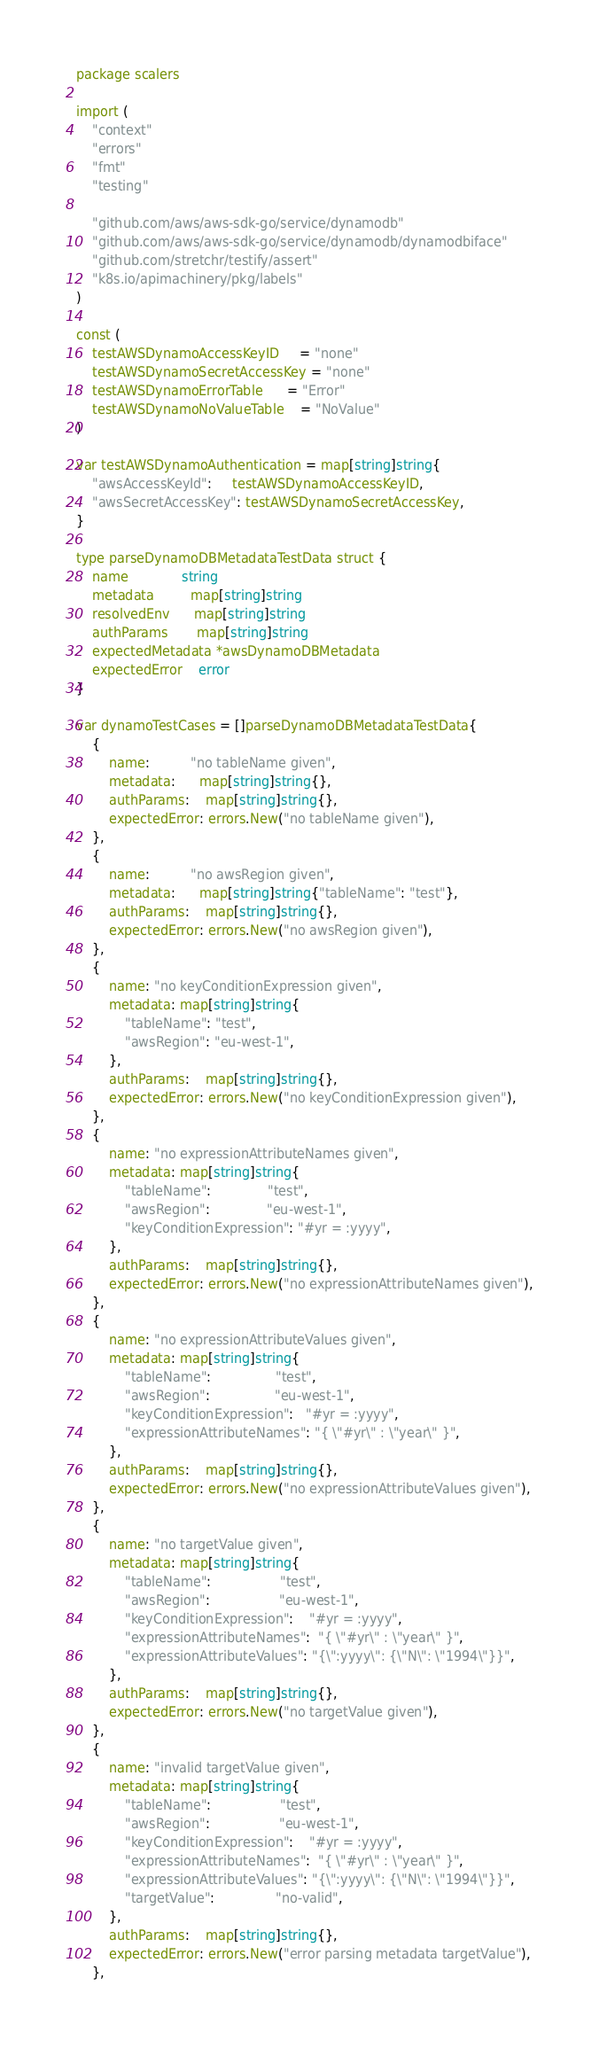Convert code to text. <code><loc_0><loc_0><loc_500><loc_500><_Go_>package scalers

import (
	"context"
	"errors"
	"fmt"
	"testing"

	"github.com/aws/aws-sdk-go/service/dynamodb"
	"github.com/aws/aws-sdk-go/service/dynamodb/dynamodbiface"
	"github.com/stretchr/testify/assert"
	"k8s.io/apimachinery/pkg/labels"
)

const (
	testAWSDynamoAccessKeyID     = "none"
	testAWSDynamoSecretAccessKey = "none"
	testAWSDynamoErrorTable      = "Error"
	testAWSDynamoNoValueTable    = "NoValue"
)

var testAWSDynamoAuthentication = map[string]string{
	"awsAccessKeyId":     testAWSDynamoAccessKeyID,
	"awsSecretAccessKey": testAWSDynamoSecretAccessKey,
}

type parseDynamoDBMetadataTestData struct {
	name             string
	metadata         map[string]string
	resolvedEnv      map[string]string
	authParams       map[string]string
	expectedMetadata *awsDynamoDBMetadata
	expectedError    error
}

var dynamoTestCases = []parseDynamoDBMetadataTestData{
	{
		name:          "no tableName given",
		metadata:      map[string]string{},
		authParams:    map[string]string{},
		expectedError: errors.New("no tableName given"),
	},
	{
		name:          "no awsRegion given",
		metadata:      map[string]string{"tableName": "test"},
		authParams:    map[string]string{},
		expectedError: errors.New("no awsRegion given"),
	},
	{
		name: "no keyConditionExpression given",
		metadata: map[string]string{
			"tableName": "test",
			"awsRegion": "eu-west-1",
		},
		authParams:    map[string]string{},
		expectedError: errors.New("no keyConditionExpression given"),
	},
	{
		name: "no expressionAttributeNames given",
		metadata: map[string]string{
			"tableName":              "test",
			"awsRegion":              "eu-west-1",
			"keyConditionExpression": "#yr = :yyyy",
		},
		authParams:    map[string]string{},
		expectedError: errors.New("no expressionAttributeNames given"),
	},
	{
		name: "no expressionAttributeValues given",
		metadata: map[string]string{
			"tableName":                "test",
			"awsRegion":                "eu-west-1",
			"keyConditionExpression":   "#yr = :yyyy",
			"expressionAttributeNames": "{ \"#yr\" : \"year\" }",
		},
		authParams:    map[string]string{},
		expectedError: errors.New("no expressionAttributeValues given"),
	},
	{
		name: "no targetValue given",
		metadata: map[string]string{
			"tableName":                 "test",
			"awsRegion":                 "eu-west-1",
			"keyConditionExpression":    "#yr = :yyyy",
			"expressionAttributeNames":  "{ \"#yr\" : \"year\" }",
			"expressionAttributeValues": "{\":yyyy\": {\"N\": \"1994\"}}",
		},
		authParams:    map[string]string{},
		expectedError: errors.New("no targetValue given"),
	},
	{
		name: "invalid targetValue given",
		metadata: map[string]string{
			"tableName":                 "test",
			"awsRegion":                 "eu-west-1",
			"keyConditionExpression":    "#yr = :yyyy",
			"expressionAttributeNames":  "{ \"#yr\" : \"year\" }",
			"expressionAttributeValues": "{\":yyyy\": {\"N\": \"1994\"}}",
			"targetValue":               "no-valid",
		},
		authParams:    map[string]string{},
		expectedError: errors.New("error parsing metadata targetValue"),
	},</code> 